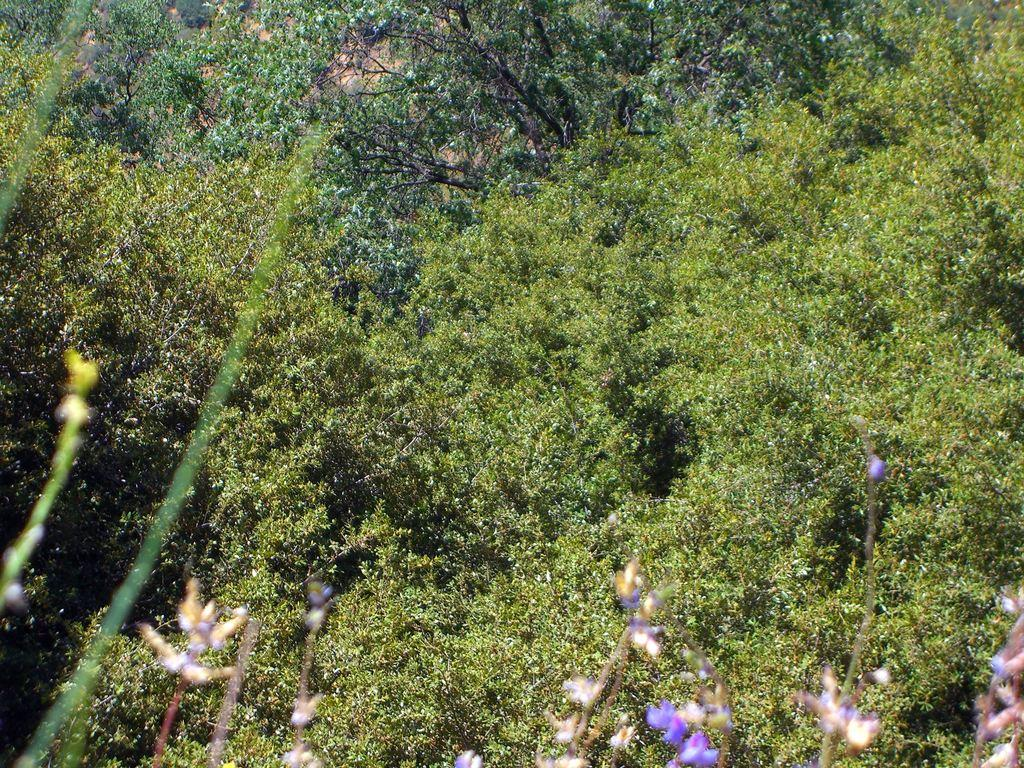What type of vegetation is present in the image? There are trees with green leaves in the image. What other flora can be seen in the image? There are flowers of different colors at the bottom of the image. Where is the aunt sitting in the image? There is no aunt present in the image. What type of loaf is being served in the image? There is no loaf present in the image. 